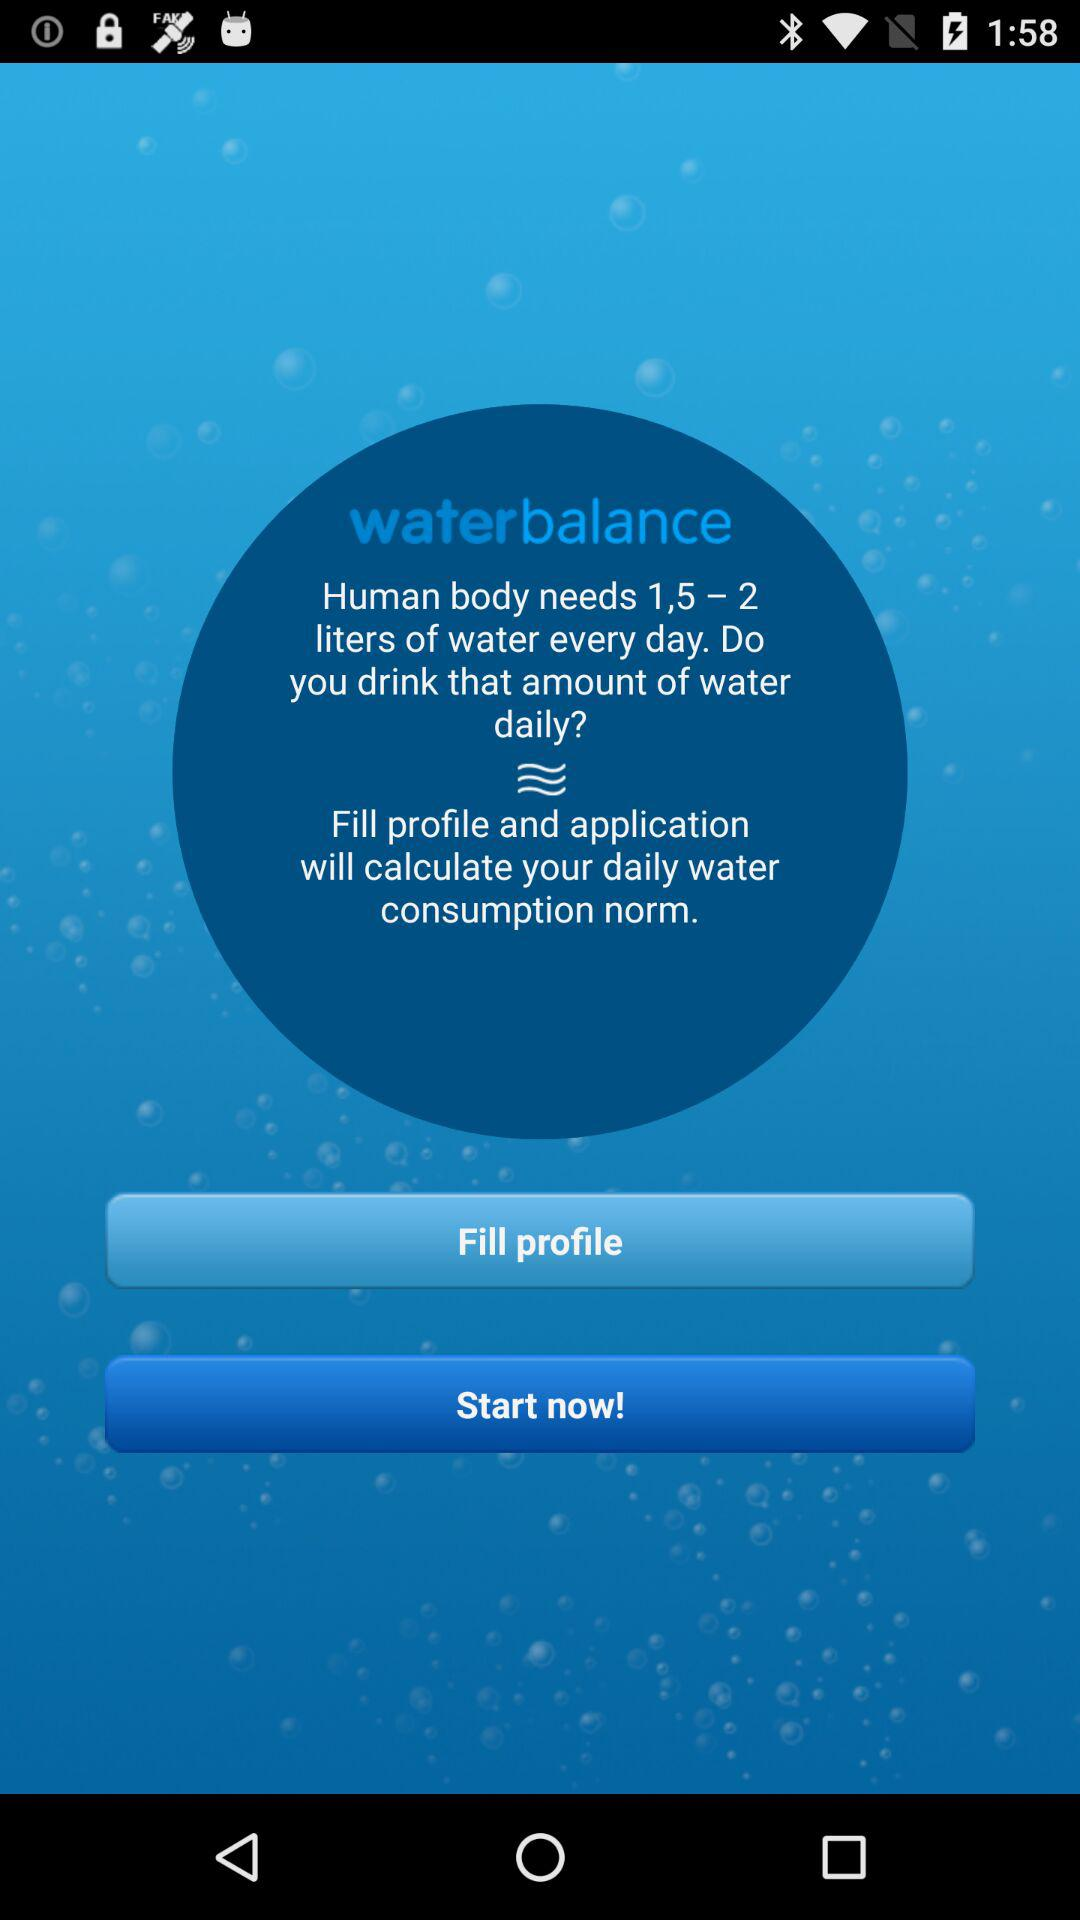What is the name of the application? The name of the application is "waterbalance". 